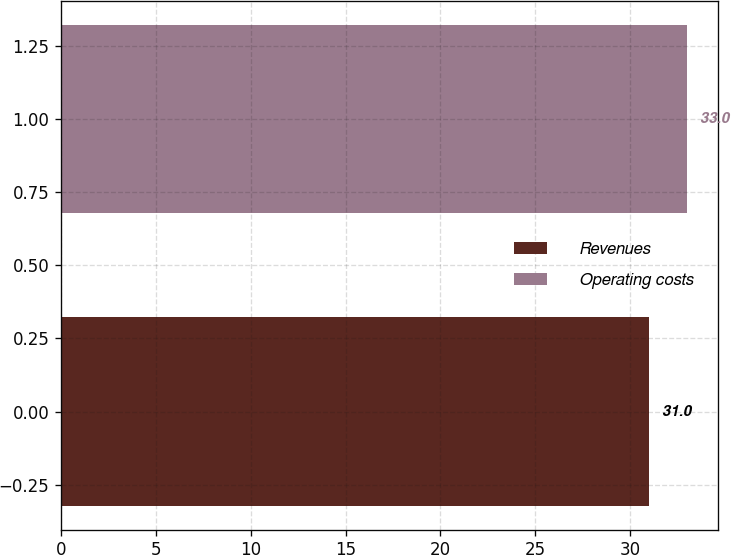<chart> <loc_0><loc_0><loc_500><loc_500><bar_chart><fcel>Revenues<fcel>Operating costs<nl><fcel>31<fcel>33<nl></chart> 